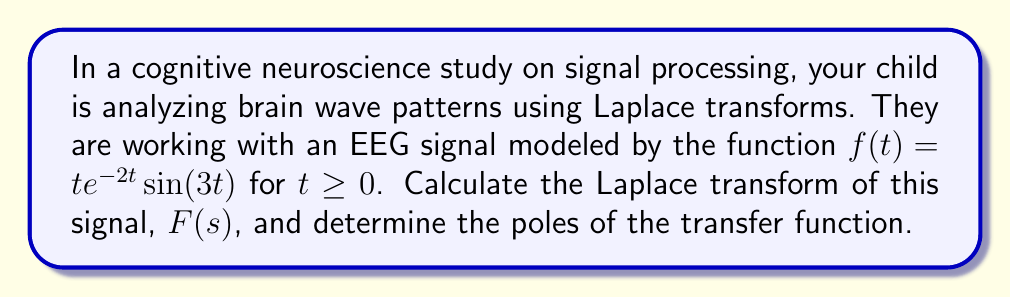Provide a solution to this math problem. Let's approach this step-by-step:

1) The Laplace transform of $f(t) = te^{-2t}\sin(3t)$ is given by:

   $$F(s) = \mathcal{L}\{te^{-2t}\sin(3t)\}$$

2) We can use the property of Laplace transforms that states:

   $$\mathcal{L}\{tf(t)\} = -\frac{d}{ds}F(s)$$

   where $F(s)$ is the Laplace transform of $f(t)$.

3) So, we first need to find the Laplace transform of $e^{-2t}\sin(3t)$:

   $$\mathcal{L}\{e^{-2t}\sin(3t)\} = \frac{3}{(s+2)^2 + 3^2}$$

4) Now, we apply the property from step 2:

   $$F(s) = -\frac{d}{ds}\left(\frac{3}{(s+2)^2 + 3^2}\right)$$

5) Differentiating:

   $$F(s) = \frac{6(s+2)}{((s+2)^2 + 3^2)^2}$$

6) To find the poles, we need to find the values of $s$ that make the denominator zero:

   $((s+2)^2 + 3^2)^2 = 0$

   $(s+2)^2 + 3^2 = 0$
   
   $(s+2)^2 = -9$
   
   $s+2 = \pm 3i$
   
   $s = -2 \pm 3i$

Thus, the poles are at $s = -2 + 3i$ and $s = -2 - 3i$.
Answer: The Laplace transform is $F(s) = \frac{6(s+2)}{((s+2)^2 + 3^2)^2}$, and the poles are at $s = -2 + 3i$ and $s = -2 - 3i$. 